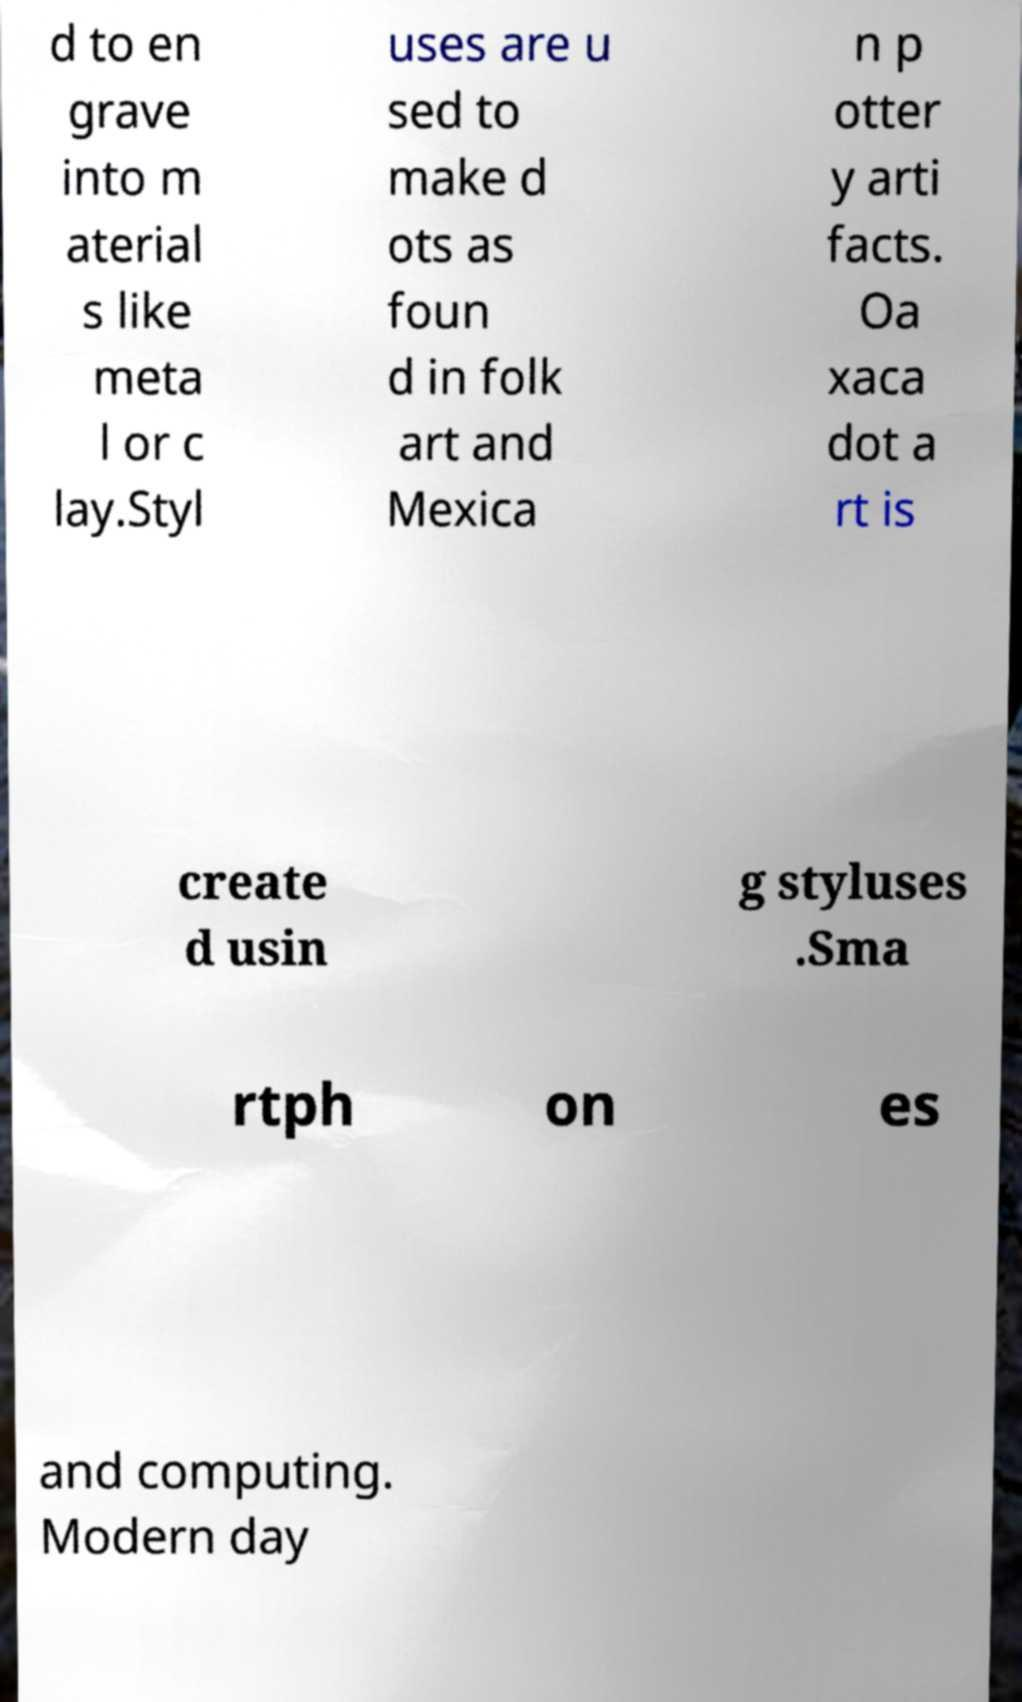Could you assist in decoding the text presented in this image and type it out clearly? d to en grave into m aterial s like meta l or c lay.Styl uses are u sed to make d ots as foun d in folk art and Mexica n p otter y arti facts. Oa xaca dot a rt is create d usin g styluses .Sma rtph on es and computing. Modern day 